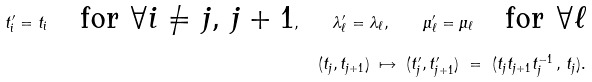<formula> <loc_0><loc_0><loc_500><loc_500>t ^ { \prime } _ { i } = t _ { i } \quad \text {for $\forall i\neq j,\, j+1$} , \quad \lambda ^ { \prime } _ { \ell } = \lambda _ { \ell } , \quad \mu ^ { \prime } _ { \ell } = \mu _ { \ell } \quad \text {for $\forall \ell$} \\ ( t _ { j } , t _ { j + 1 } ) \ \mapsto \ ( t ^ { \prime } _ { j } , t ^ { \prime } _ { j + 1 } ) \ = \ ( t _ { j } t _ { j + 1 } t _ { j } ^ { - 1 } \, , \, t _ { j } ) .</formula> 